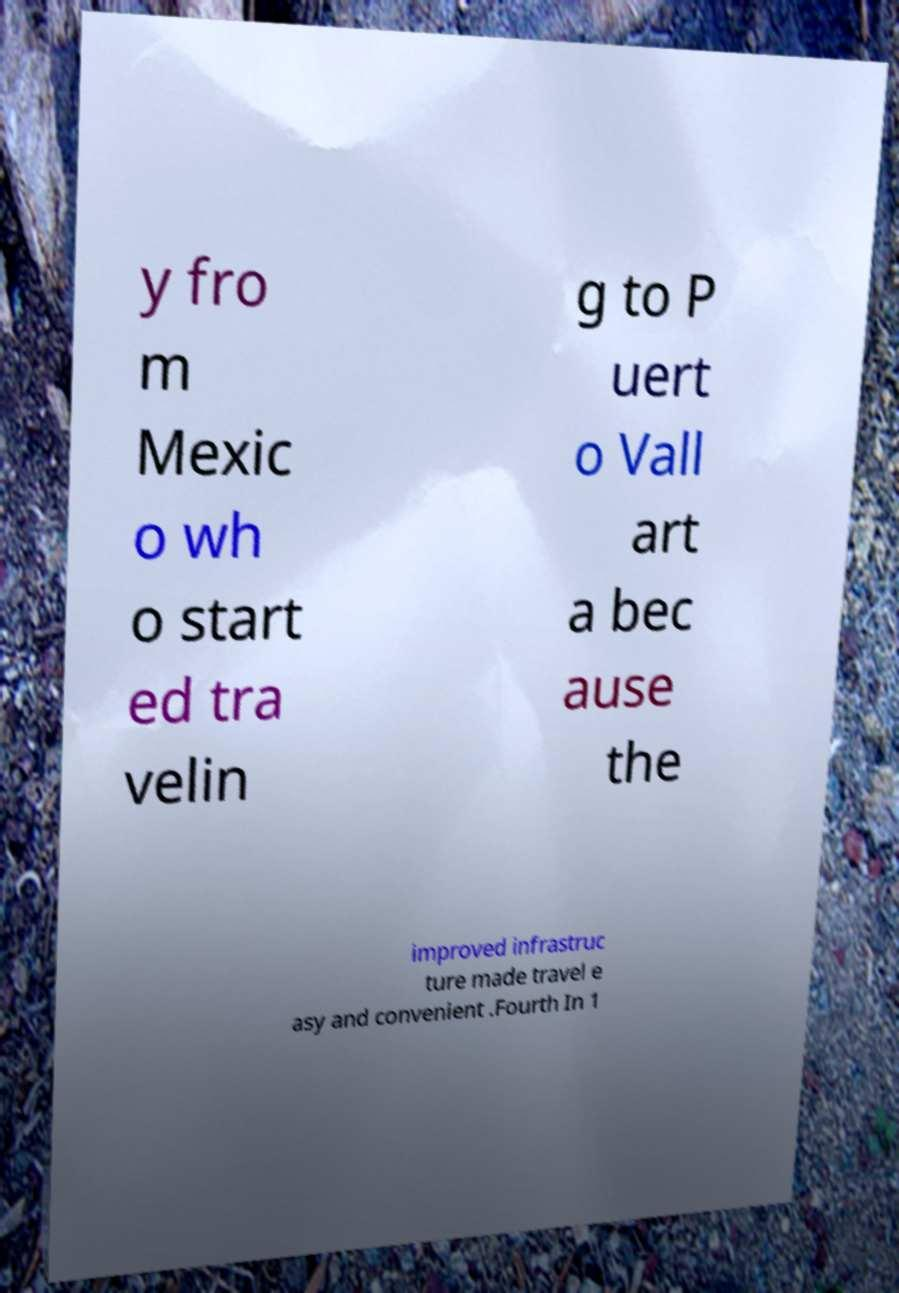I need the written content from this picture converted into text. Can you do that? y fro m Mexic o wh o start ed tra velin g to P uert o Vall art a bec ause the improved infrastruc ture made travel e asy and convenient .Fourth In 1 